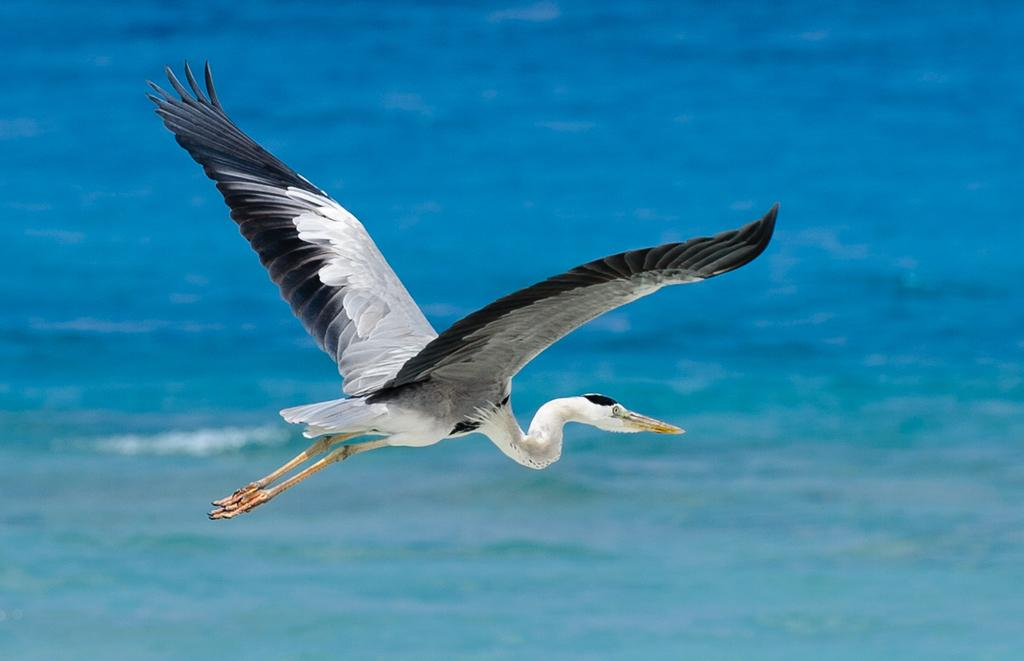What is the main subject in the center of the image? There is a crane in the center of the image. What can be seen in the background of the image? There is water visible in the background of the image. What song is the crane singing in the image? Cranes do not sing songs, and there is no indication of a song in the image. 